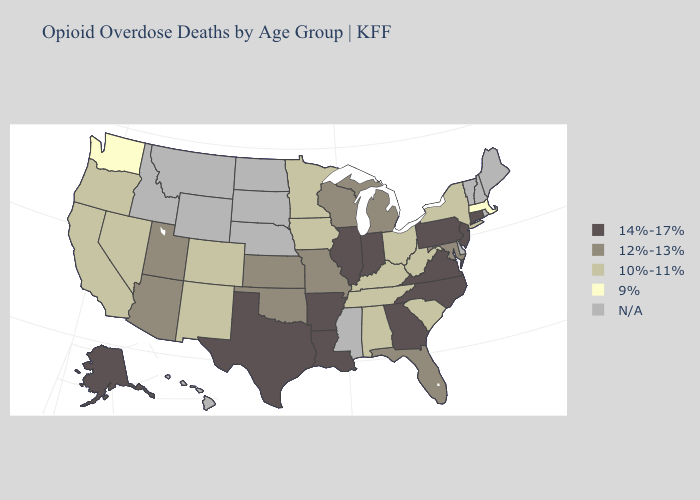What is the lowest value in the MidWest?
Keep it brief. 10%-11%. Name the states that have a value in the range 12%-13%?
Answer briefly. Arizona, Florida, Kansas, Maryland, Michigan, Missouri, Oklahoma, Utah, Wisconsin. Does Arkansas have the lowest value in the USA?
Give a very brief answer. No. What is the value of New Jersey?
Short answer required. 14%-17%. What is the value of Mississippi?
Be succinct. N/A. Does Washington have the lowest value in the West?
Write a very short answer. Yes. Which states have the highest value in the USA?
Keep it brief. Alaska, Arkansas, Connecticut, Georgia, Illinois, Indiana, Louisiana, New Jersey, North Carolina, Pennsylvania, Texas, Virginia. Name the states that have a value in the range 10%-11%?
Answer briefly. Alabama, California, Colorado, Iowa, Kentucky, Minnesota, Nevada, New Mexico, New York, Ohio, Oregon, South Carolina, Tennessee, West Virginia. Name the states that have a value in the range 14%-17%?
Keep it brief. Alaska, Arkansas, Connecticut, Georgia, Illinois, Indiana, Louisiana, New Jersey, North Carolina, Pennsylvania, Texas, Virginia. Name the states that have a value in the range N/A?
Short answer required. Delaware, Hawaii, Idaho, Maine, Mississippi, Montana, Nebraska, New Hampshire, North Dakota, Rhode Island, South Dakota, Vermont, Wyoming. Name the states that have a value in the range 14%-17%?
Keep it brief. Alaska, Arkansas, Connecticut, Georgia, Illinois, Indiana, Louisiana, New Jersey, North Carolina, Pennsylvania, Texas, Virginia. Which states have the lowest value in the Northeast?
Answer briefly. Massachusetts. What is the lowest value in states that border Wyoming?
Keep it brief. 10%-11%. Name the states that have a value in the range 14%-17%?
Short answer required. Alaska, Arkansas, Connecticut, Georgia, Illinois, Indiana, Louisiana, New Jersey, North Carolina, Pennsylvania, Texas, Virginia. 